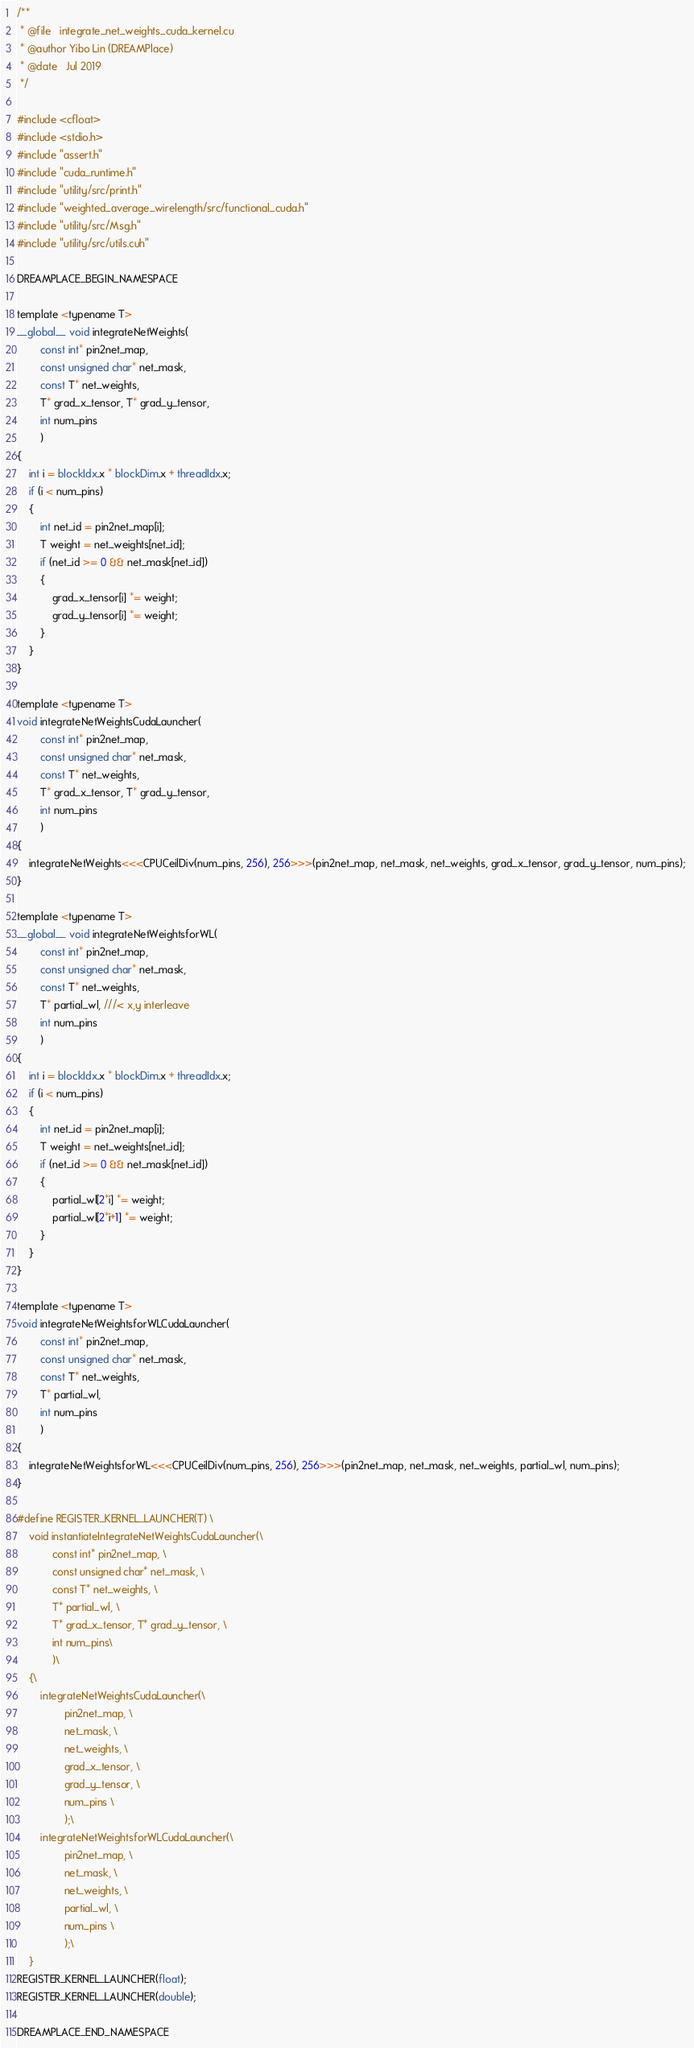Convert code to text. <code><loc_0><loc_0><loc_500><loc_500><_Cuda_>/**
 * @file   integrate_net_weights_cuda_kernel.cu
 * @author Yibo Lin (DREAMPlace)
 * @date   Jul 2019
 */

#include <cfloat>
#include <stdio.h>
#include "assert.h"
#include "cuda_runtime.h"
#include "utility/src/print.h"
#include "weighted_average_wirelength/src/functional_cuda.h"
#include "utility/src/Msg.h"
#include "utility/src/utils.cuh"

DREAMPLACE_BEGIN_NAMESPACE

template <typename T>
__global__ void integrateNetWeights(
        const int* pin2net_map, 
        const unsigned char* net_mask, 
        const T* net_weights, 
        T* grad_x_tensor, T* grad_y_tensor, 
        int num_pins
        )
{
    int i = blockIdx.x * blockDim.x + threadIdx.x;
    if (i < num_pins)
    {
        int net_id = pin2net_map[i]; 
        T weight = net_weights[net_id]; 
        if (net_id >= 0 && net_mask[net_id])
        {
            grad_x_tensor[i] *= weight; 
            grad_y_tensor[i] *= weight; 
        }
    }
}

template <typename T>
void integrateNetWeightsCudaLauncher(
        const int* pin2net_map, 
        const unsigned char* net_mask, 
        const T* net_weights, 
        T* grad_x_tensor, T* grad_y_tensor, 
        int num_pins
        )
{
    integrateNetWeights<<<CPUCeilDiv(num_pins, 256), 256>>>(pin2net_map, net_mask, net_weights, grad_x_tensor, grad_y_tensor, num_pins); 
}

template <typename T>
__global__ void integrateNetWeightsforWL(
        const int* pin2net_map, 
        const unsigned char* net_mask, 
        const T* net_weights, 
        T* partial_wl, ///< x,y interleave
        int num_pins
        )
{
    int i = blockIdx.x * blockDim.x + threadIdx.x;
    if (i < num_pins)
    {
        int net_id = pin2net_map[i]; 
        T weight = net_weights[net_id]; 
        if (net_id >= 0 && net_mask[net_id])
        {
            partial_wl[2*i] *= weight; 
            partial_wl[2*i+1] *= weight; 
        }
    }
}

template <typename T>
void integrateNetWeightsforWLCudaLauncher(
        const int* pin2net_map, 
        const unsigned char* net_mask, 
        const T* net_weights, 
        T* partial_wl, 
        int num_pins
        )
{
    integrateNetWeightsforWL<<<CPUCeilDiv(num_pins, 256), 256>>>(pin2net_map, net_mask, net_weights, partial_wl, num_pins); 
}

#define REGISTER_KERNEL_LAUNCHER(T) \
    void instantiateIntegrateNetWeightsCudaLauncher(\
            const int* pin2net_map, \
            const unsigned char* net_mask, \
            const T* net_weights, \
            T* partial_wl, \
            T* grad_x_tensor, T* grad_y_tensor, \
            int num_pins\
            )\
    {\
        integrateNetWeightsCudaLauncher(\
                pin2net_map, \
                net_mask, \
                net_weights, \
                grad_x_tensor, \
                grad_y_tensor, \
                num_pins \
                );\
        integrateNetWeightsforWLCudaLauncher(\
                pin2net_map, \
                net_mask, \
                net_weights, \
                partial_wl, \
                num_pins \
                );\
    }
REGISTER_KERNEL_LAUNCHER(float);
REGISTER_KERNEL_LAUNCHER(double);

DREAMPLACE_END_NAMESPACE
</code> 